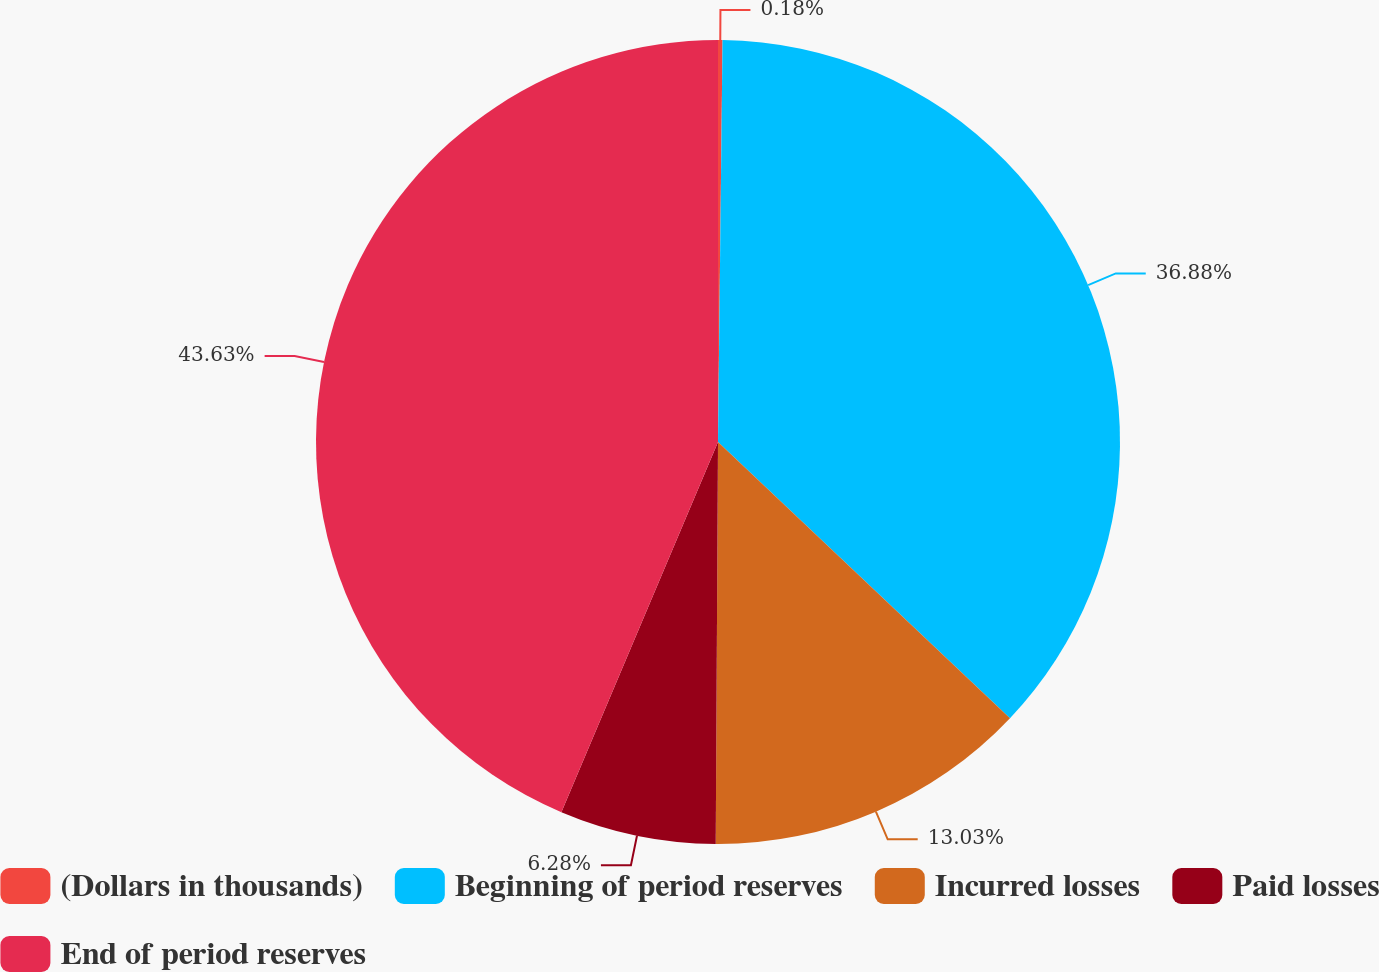Convert chart. <chart><loc_0><loc_0><loc_500><loc_500><pie_chart><fcel>(Dollars in thousands)<fcel>Beginning of period reserves<fcel>Incurred losses<fcel>Paid losses<fcel>End of period reserves<nl><fcel>0.18%<fcel>36.88%<fcel>13.03%<fcel>6.28%<fcel>43.63%<nl></chart> 